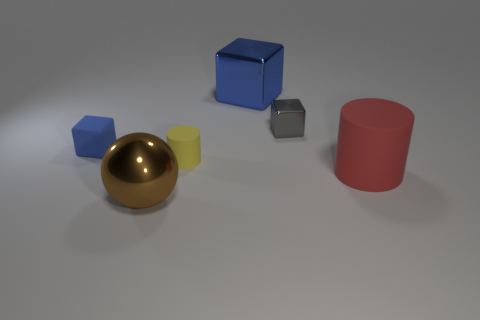How many cylinders are to the left of the small blue matte thing? There are zero cylinders to the left of the small blue cube when facing them head-on. The only objects present are two cubes, a small shiny gold sphere, a small metallic cube, and a red cylinder, which is to the right of the blue cube. 